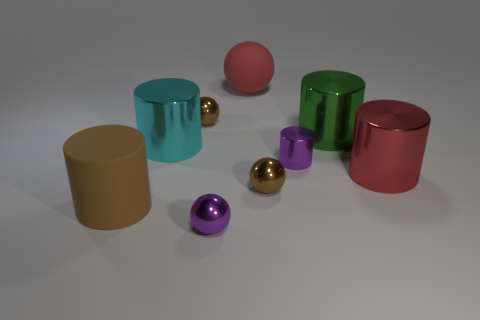Subtract all tiny purple shiny cylinders. How many cylinders are left? 4 Subtract all purple cylinders. How many brown balls are left? 2 Subtract 2 spheres. How many spheres are left? 2 Subtract all purple spheres. How many spheres are left? 3 Add 1 small cylinders. How many objects exist? 10 Subtract all green cylinders. Subtract all brown spheres. How many cylinders are left? 4 Subtract all spheres. How many objects are left? 5 Add 2 big red rubber objects. How many big red rubber objects exist? 3 Subtract 0 red cubes. How many objects are left? 9 Subtract all cyan objects. Subtract all small blue shiny cylinders. How many objects are left? 8 